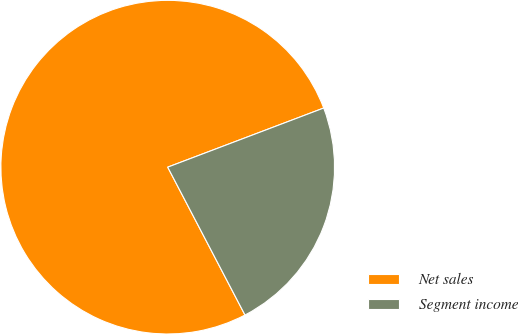Convert chart. <chart><loc_0><loc_0><loc_500><loc_500><pie_chart><fcel>Net sales<fcel>Segment income<nl><fcel>76.9%<fcel>23.1%<nl></chart> 